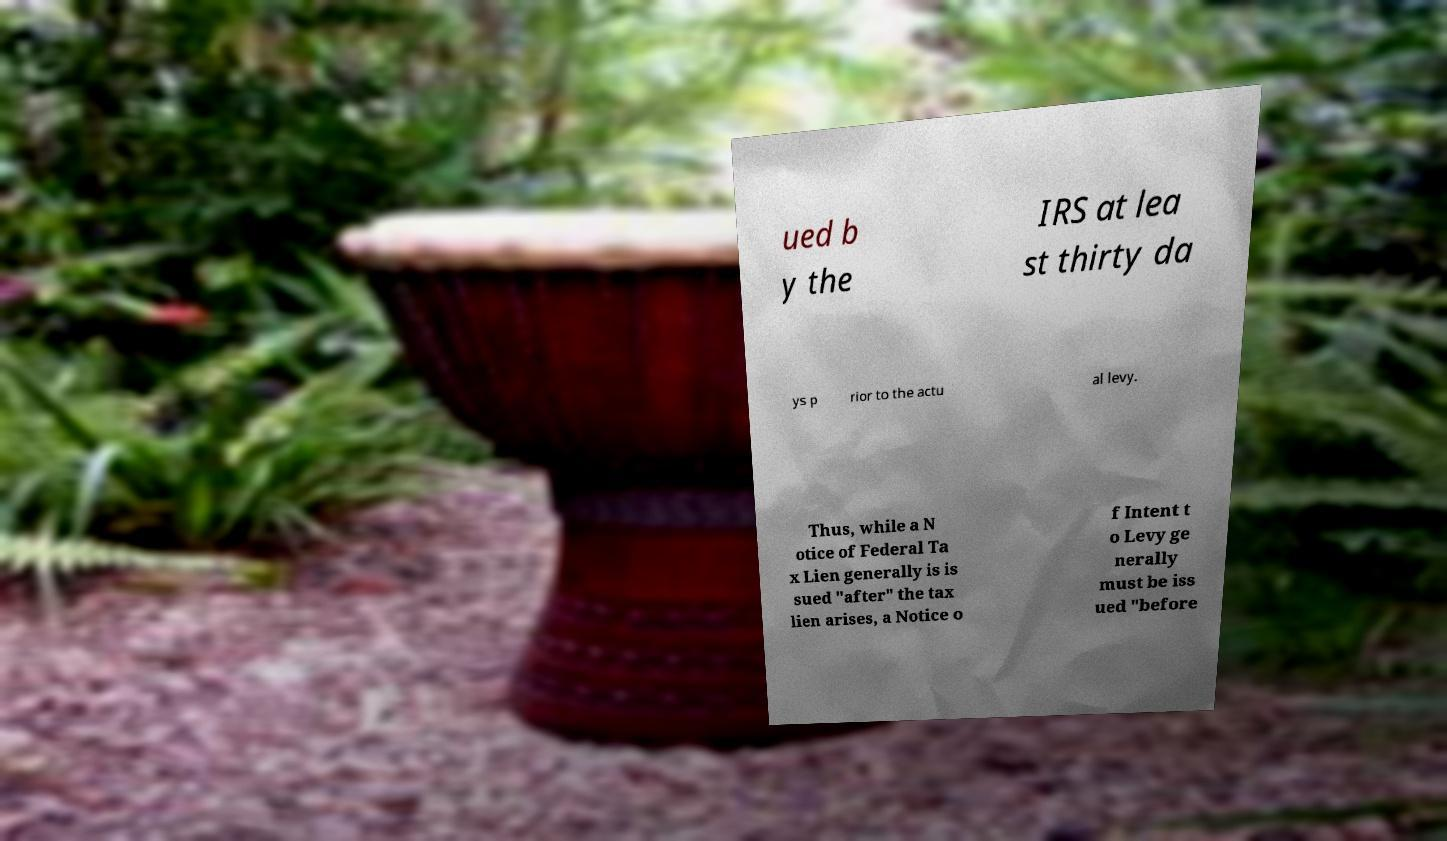I need the written content from this picture converted into text. Can you do that? ued b y the IRS at lea st thirty da ys p rior to the actu al levy. Thus, while a N otice of Federal Ta x Lien generally is is sued "after" the tax lien arises, a Notice o f Intent t o Levy ge nerally must be iss ued "before 